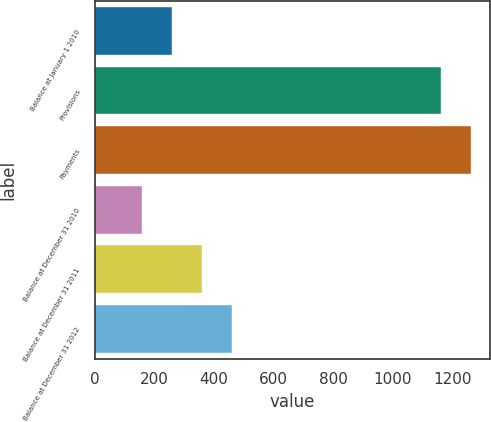Convert chart. <chart><loc_0><loc_0><loc_500><loc_500><bar_chart><fcel>Balance at January 1 2010<fcel>Provisions<fcel>Payments<fcel>Balance at December 31 2010<fcel>Balance at December 31 2011<fcel>Balance at December 31 2012<nl><fcel>259.4<fcel>1162<fcel>1262.4<fcel>159<fcel>359.8<fcel>460.2<nl></chart> 